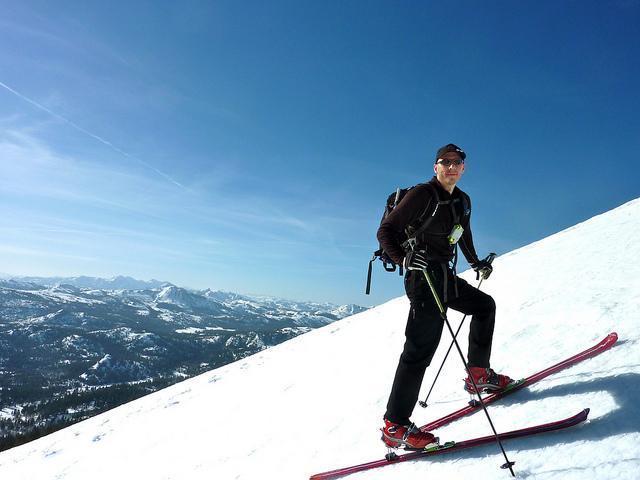How many of the zebras are standing up?
Give a very brief answer. 0. 